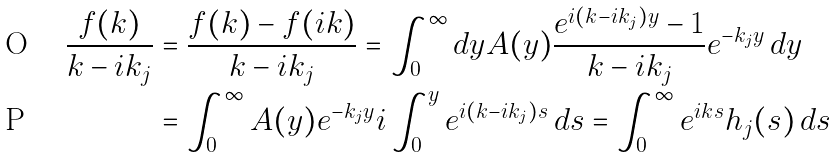Convert formula to latex. <formula><loc_0><loc_0><loc_500><loc_500>\frac { f ( k ) } { k - i k _ { j } } & = \frac { f ( k ) - f ( i k ) } { k - i k _ { j } } = \int ^ { \infty } _ { 0 } d y A ( y ) \frac { e ^ { i ( k - i k _ { j } ) y } - 1 } { k - i k _ { j } } e ^ { - k _ { j } y } \, d y \\ & = \int ^ { \infty } _ { 0 } A ( y ) e ^ { - k _ { j } y } i \int ^ { y } _ { 0 } e ^ { i ( k - i k _ { j } ) s } \, d s = \int ^ { \infty } _ { 0 } e ^ { i k s } h _ { j } ( s ) \, d s</formula> 